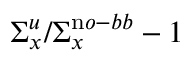Convert formula to latex. <formula><loc_0><loc_0><loc_500><loc_500>\Sigma _ { x } ^ { u } / \Sigma _ { x } ^ { \mathrm n o - b b } - 1</formula> 